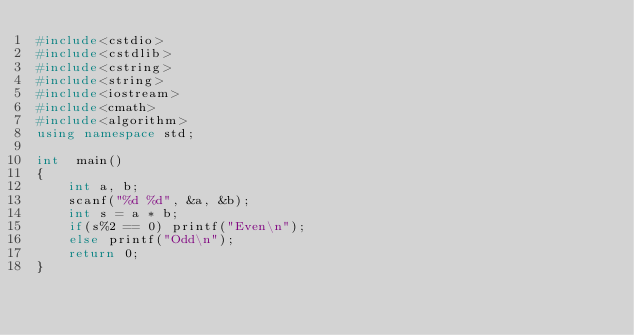<code> <loc_0><loc_0><loc_500><loc_500><_C++_>#include<cstdio>
#include<cstdlib>
#include<cstring>
#include<string>
#include<iostream>
#include<cmath>
#include<algorithm>
using namespace std;

int  main()
{
	int a, b;
	scanf("%d %d", &a, &b);
	int s = a * b;
	if(s%2 == 0) printf("Even\n");
	else printf("Odd\n");
	return 0;
}</code> 